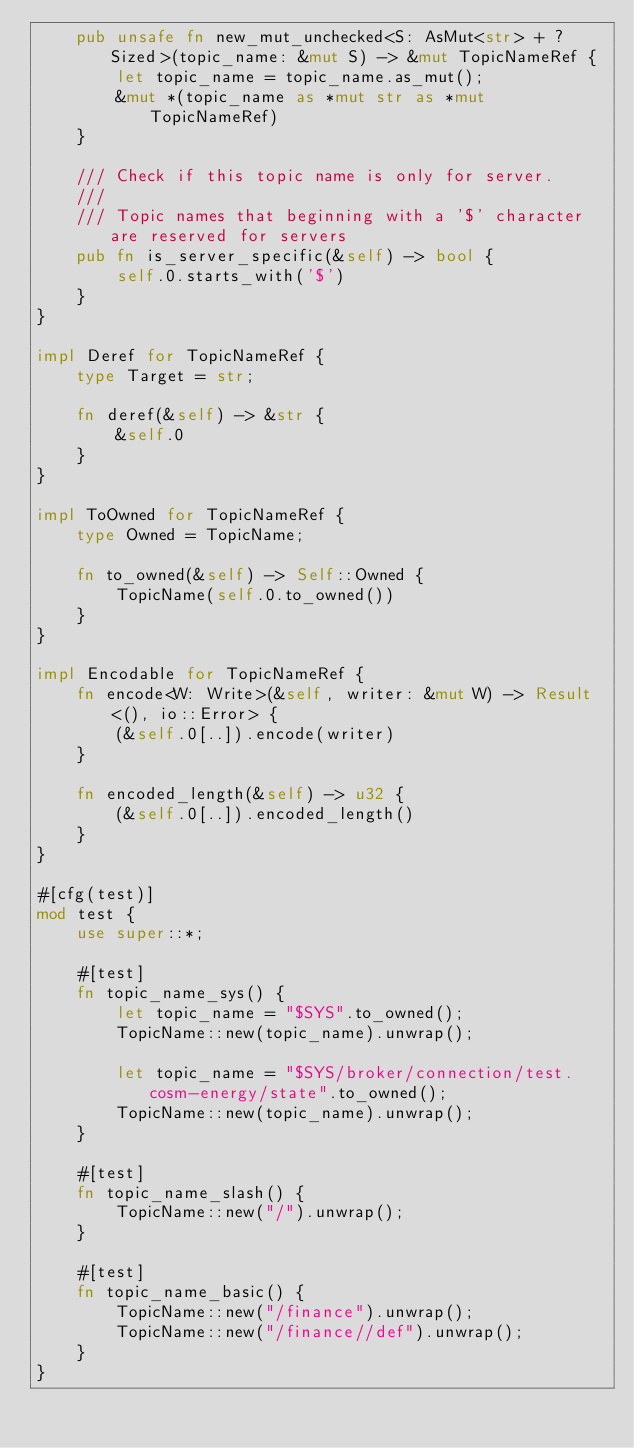Convert code to text. <code><loc_0><loc_0><loc_500><loc_500><_Rust_>    pub unsafe fn new_mut_unchecked<S: AsMut<str> + ?Sized>(topic_name: &mut S) -> &mut TopicNameRef {
        let topic_name = topic_name.as_mut();
        &mut *(topic_name as *mut str as *mut TopicNameRef)
    }

    /// Check if this topic name is only for server.
    ///
    /// Topic names that beginning with a '$' character are reserved for servers
    pub fn is_server_specific(&self) -> bool {
        self.0.starts_with('$')
    }
}

impl Deref for TopicNameRef {
    type Target = str;

    fn deref(&self) -> &str {
        &self.0
    }
}

impl ToOwned for TopicNameRef {
    type Owned = TopicName;

    fn to_owned(&self) -> Self::Owned {
        TopicName(self.0.to_owned())
    }
}

impl Encodable for TopicNameRef {
    fn encode<W: Write>(&self, writer: &mut W) -> Result<(), io::Error> {
        (&self.0[..]).encode(writer)
    }

    fn encoded_length(&self) -> u32 {
        (&self.0[..]).encoded_length()
    }
}

#[cfg(test)]
mod test {
    use super::*;

    #[test]
    fn topic_name_sys() {
        let topic_name = "$SYS".to_owned();
        TopicName::new(topic_name).unwrap();

        let topic_name = "$SYS/broker/connection/test.cosm-energy/state".to_owned();
        TopicName::new(topic_name).unwrap();
    }

    #[test]
    fn topic_name_slash() {
        TopicName::new("/").unwrap();
    }

    #[test]
    fn topic_name_basic() {
        TopicName::new("/finance").unwrap();
        TopicName::new("/finance//def").unwrap();
    }
}
</code> 